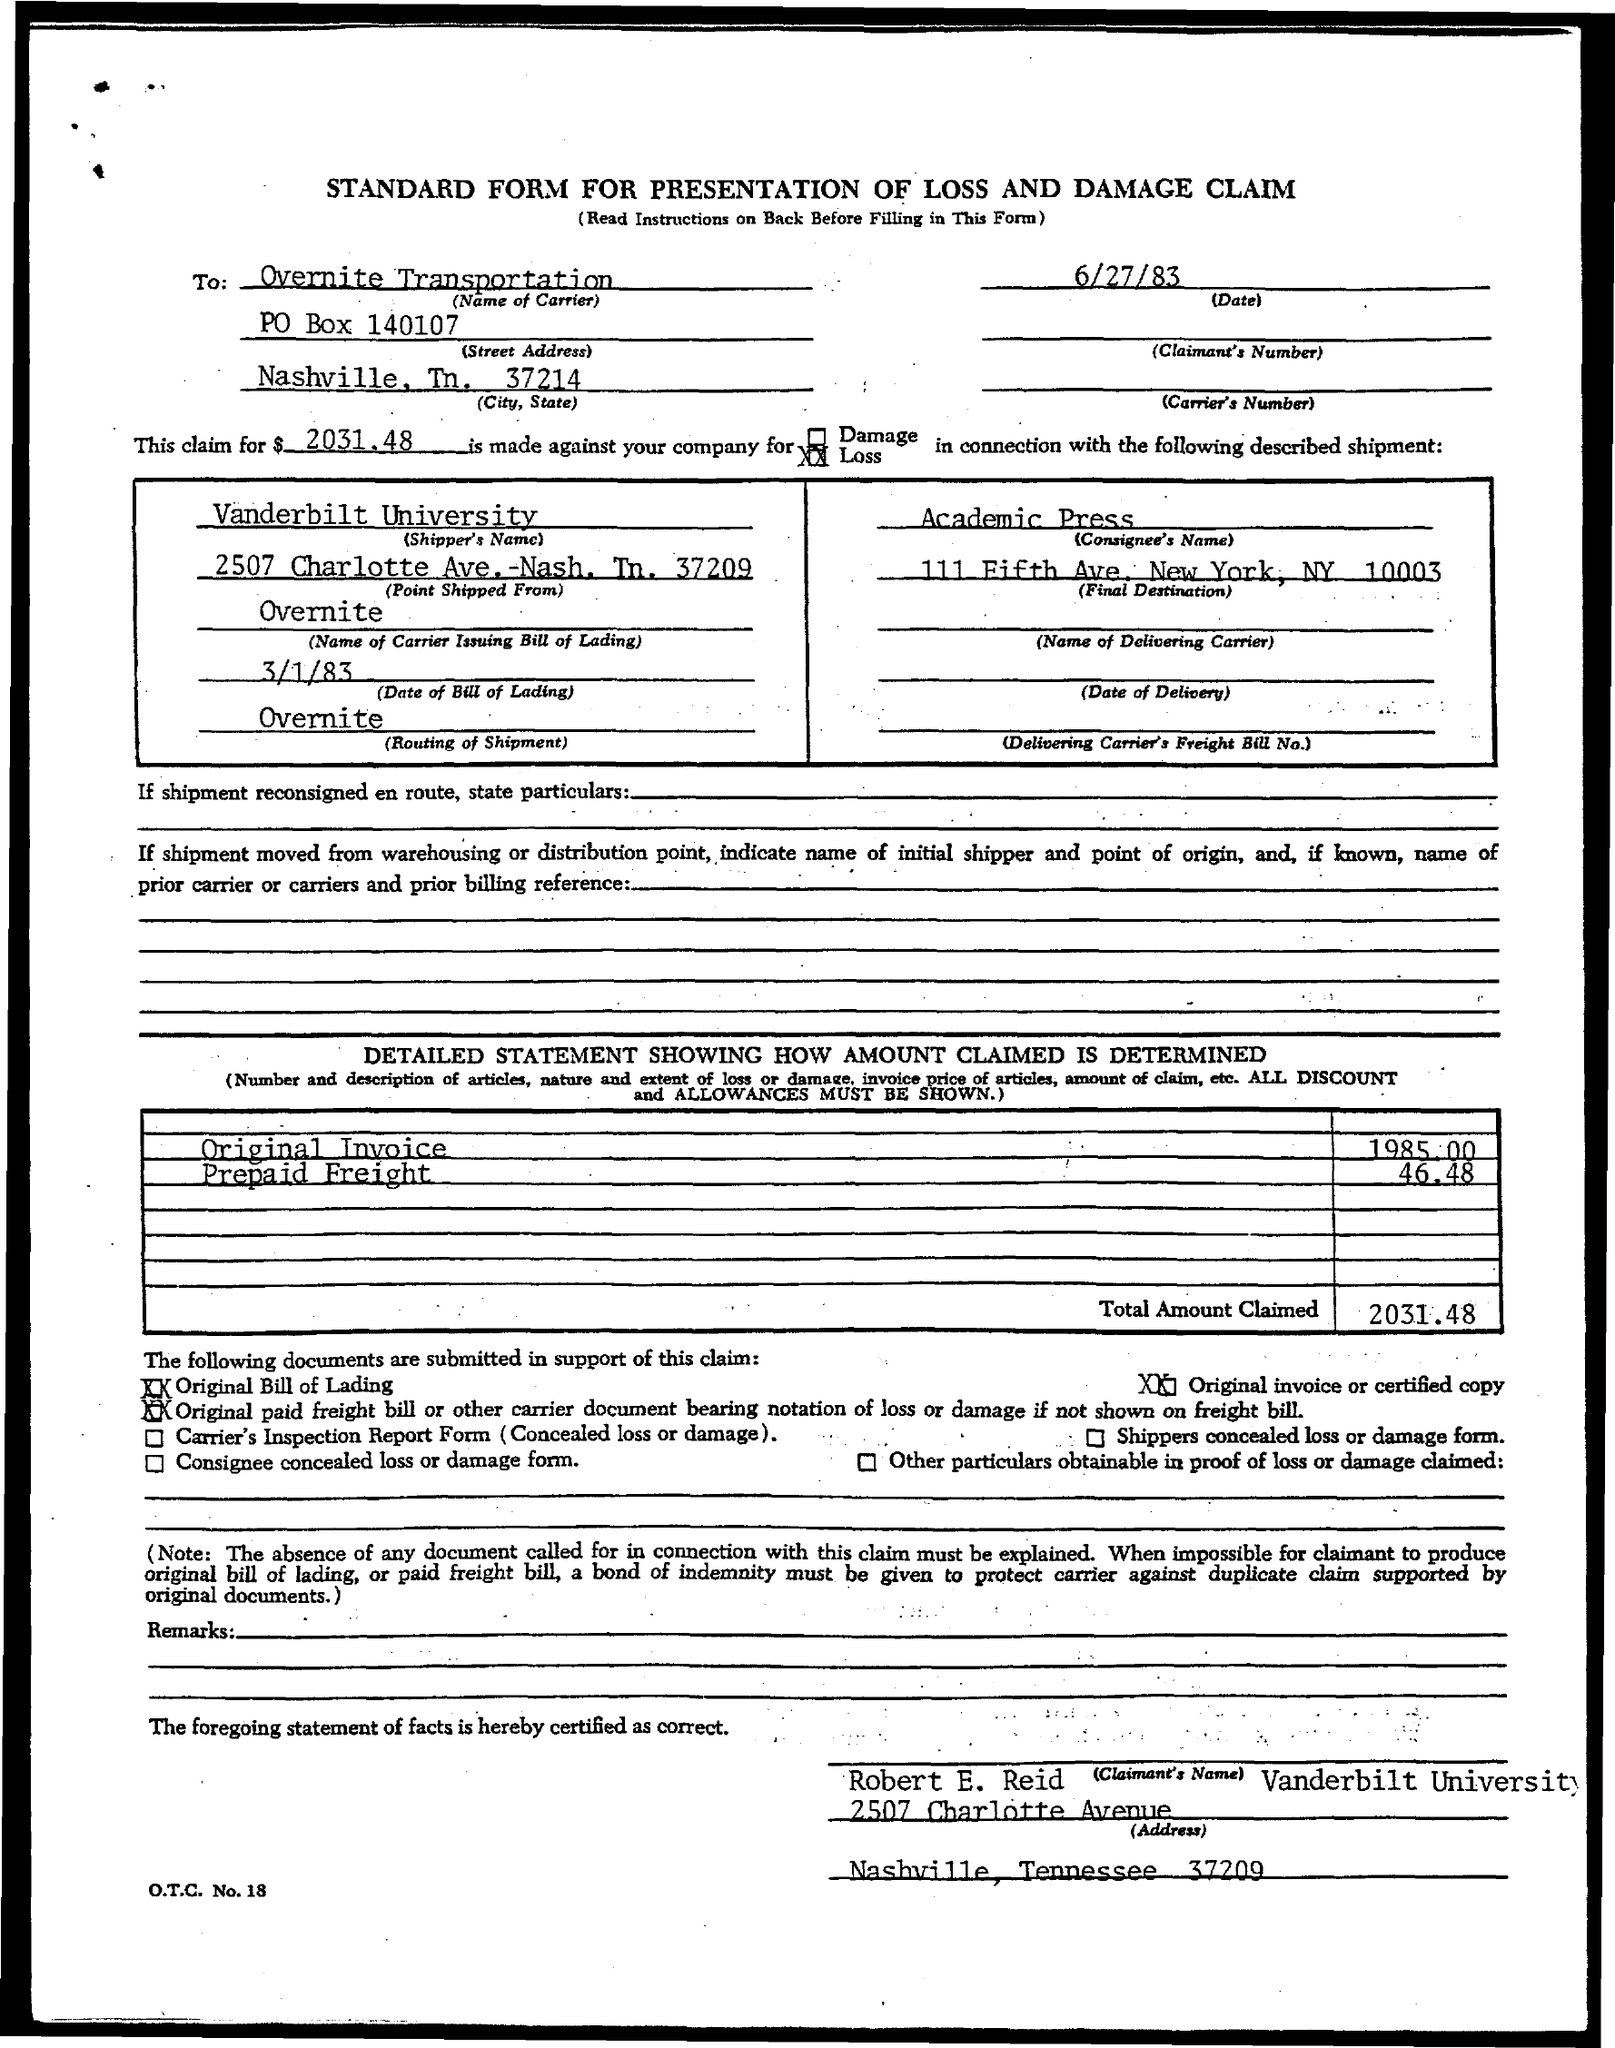Give some essential details in this illustration. The claimed amount is $2031.48. The Carrier Issuing Bill of Lading is the name of Overnite. The consignee's name is Academic Press. The point of shipment is located at 2507 Charlotte Ave. in Nashville, Tennessee 37209. I'm sorry, but I'm not sure what you are trying to say. Can you please provide more context or clarify your question? 